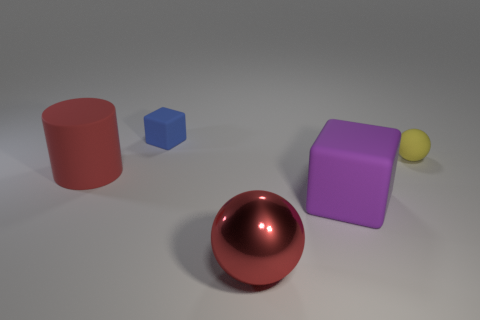Add 1 spheres. How many objects exist? 6 Subtract all cubes. How many objects are left? 3 Add 3 yellow spheres. How many yellow spheres exist? 4 Subtract 0 green spheres. How many objects are left? 5 Subtract all purple things. Subtract all small blocks. How many objects are left? 3 Add 2 red rubber objects. How many red rubber objects are left? 3 